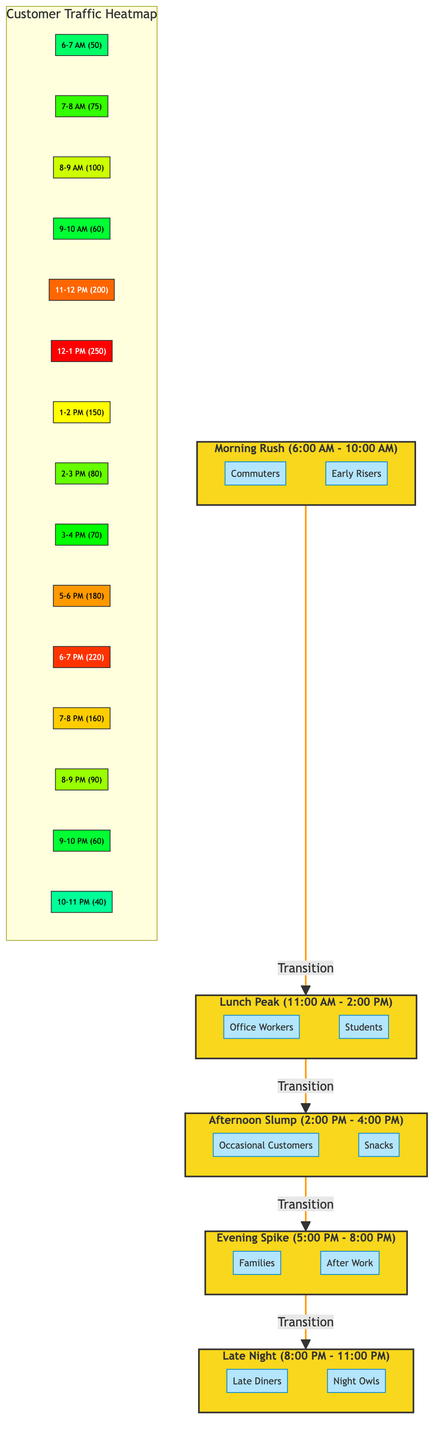What is the highest customer traffic recorded? The highest customer traffic is indicated in the heatmap section of the diagram, where the value 250 in the 12-1 PM slot represents the peak traffic.
Answer: 250 During which time slot was the traffic the lowest? The heatmap shows that the lowest customer traffic is recorded in the 10-11 PM time slot, which is indicated by the value 40.
Answer: 40 How many distinct customer categories are identified in the morning section? There are two distinct customer categories in the morning rush segment: Commuters and Early Risers, as shown in the corresponding nodes.
Answer: 2 Which time slot has traffic that exceeds 200 customers? Referring to the heatmap, the time slots of 11-12 PM and 12-1 PM both have traffic exceeding 200, with values of 200 and 250, respectively.
Answer: 11-12 PM and 12-1 PM What is the transition order of the customer traffic segments? The flow of segments shows a clear order: Morning rush leads to Lunch peak, which subsequently transitions to Afternoon slump, then Evening spike, and finally to Late Night.
Answer: Morning Rush, Lunch Peak, Afternoon Slump, Evening Spike, Late Night What is the customer traffic during the period of 5-6 PM? The heatmap illustrates that during the 5-6 PM period, the customer traffic is recorded at a value of 180.
Answer: 180 How many time slots are shown in the heatmap? In the heatmap, there are a total of 12 distinct time slots represented from 6 AM to 11 PM.
Answer: 12 Which customer group is associated with the evening spike? The evening spike segment includes two customer groups: Families and After Work, as specified in the entity nodes under the Evening section.
Answer: Families and After Work What color represents traffic of 100 customers on the heatmap? The heatmap assigns the color green (specifically #ccff00) to the time slot with 100 customers, which can be seen in the 8-9 AM entry.
Answer: green 